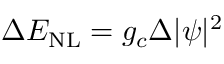Convert formula to latex. <formula><loc_0><loc_0><loc_500><loc_500>\Delta E _ { N L } = g _ { c } \Delta | \psi | ^ { 2 }</formula> 